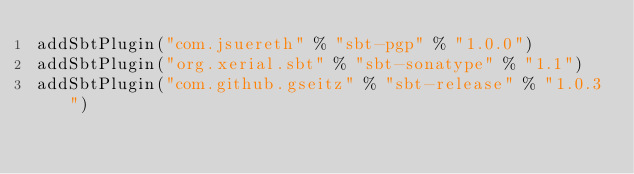<code> <loc_0><loc_0><loc_500><loc_500><_Scala_>addSbtPlugin("com.jsuereth" % "sbt-pgp" % "1.0.0")
addSbtPlugin("org.xerial.sbt" % "sbt-sonatype" % "1.1")
addSbtPlugin("com.github.gseitz" % "sbt-release" % "1.0.3")</code> 